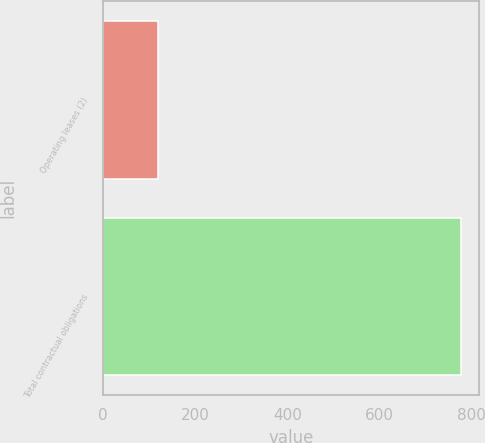Convert chart to OTSL. <chart><loc_0><loc_0><loc_500><loc_500><bar_chart><fcel>Operating leases (2)<fcel>Total contractual obligations<nl><fcel>120<fcel>778<nl></chart> 